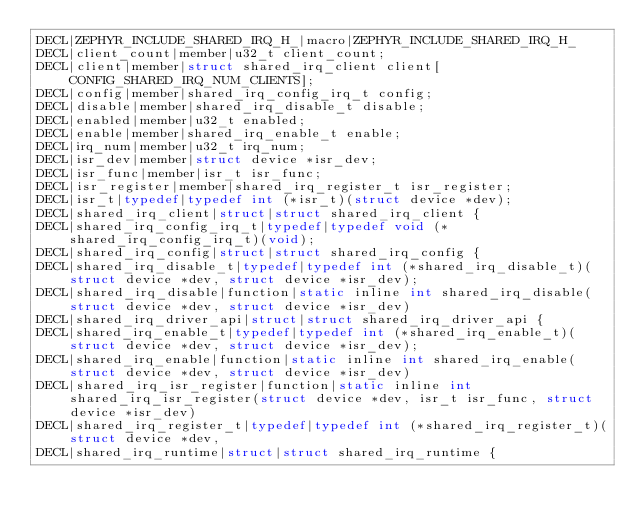<code> <loc_0><loc_0><loc_500><loc_500><_C_>DECL|ZEPHYR_INCLUDE_SHARED_IRQ_H_|macro|ZEPHYR_INCLUDE_SHARED_IRQ_H_
DECL|client_count|member|u32_t client_count;
DECL|client|member|struct shared_irq_client client[CONFIG_SHARED_IRQ_NUM_CLIENTS];
DECL|config|member|shared_irq_config_irq_t config;
DECL|disable|member|shared_irq_disable_t disable;
DECL|enabled|member|u32_t enabled;
DECL|enable|member|shared_irq_enable_t enable;
DECL|irq_num|member|u32_t irq_num;
DECL|isr_dev|member|struct device *isr_dev;
DECL|isr_func|member|isr_t isr_func;
DECL|isr_register|member|shared_irq_register_t isr_register;
DECL|isr_t|typedef|typedef int (*isr_t)(struct device *dev);
DECL|shared_irq_client|struct|struct shared_irq_client {
DECL|shared_irq_config_irq_t|typedef|typedef void (*shared_irq_config_irq_t)(void);
DECL|shared_irq_config|struct|struct shared_irq_config {
DECL|shared_irq_disable_t|typedef|typedef int (*shared_irq_disable_t)(struct device *dev, struct device *isr_dev);
DECL|shared_irq_disable|function|static inline int shared_irq_disable(struct device *dev, struct device *isr_dev)
DECL|shared_irq_driver_api|struct|struct shared_irq_driver_api {
DECL|shared_irq_enable_t|typedef|typedef int (*shared_irq_enable_t)(struct device *dev, struct device *isr_dev);
DECL|shared_irq_enable|function|static inline int shared_irq_enable(struct device *dev, struct device *isr_dev)
DECL|shared_irq_isr_register|function|static inline int shared_irq_isr_register(struct device *dev, isr_t isr_func, struct device *isr_dev)
DECL|shared_irq_register_t|typedef|typedef int (*shared_irq_register_t)(struct device *dev,
DECL|shared_irq_runtime|struct|struct shared_irq_runtime {
</code> 